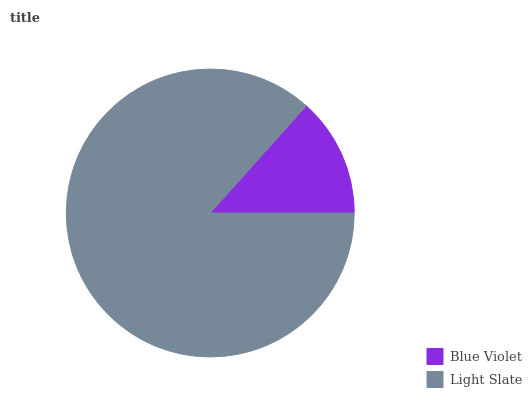Is Blue Violet the minimum?
Answer yes or no. Yes. Is Light Slate the maximum?
Answer yes or no. Yes. Is Light Slate the minimum?
Answer yes or no. No. Is Light Slate greater than Blue Violet?
Answer yes or no. Yes. Is Blue Violet less than Light Slate?
Answer yes or no. Yes. Is Blue Violet greater than Light Slate?
Answer yes or no. No. Is Light Slate less than Blue Violet?
Answer yes or no. No. Is Light Slate the high median?
Answer yes or no. Yes. Is Blue Violet the low median?
Answer yes or no. Yes. Is Blue Violet the high median?
Answer yes or no. No. Is Light Slate the low median?
Answer yes or no. No. 